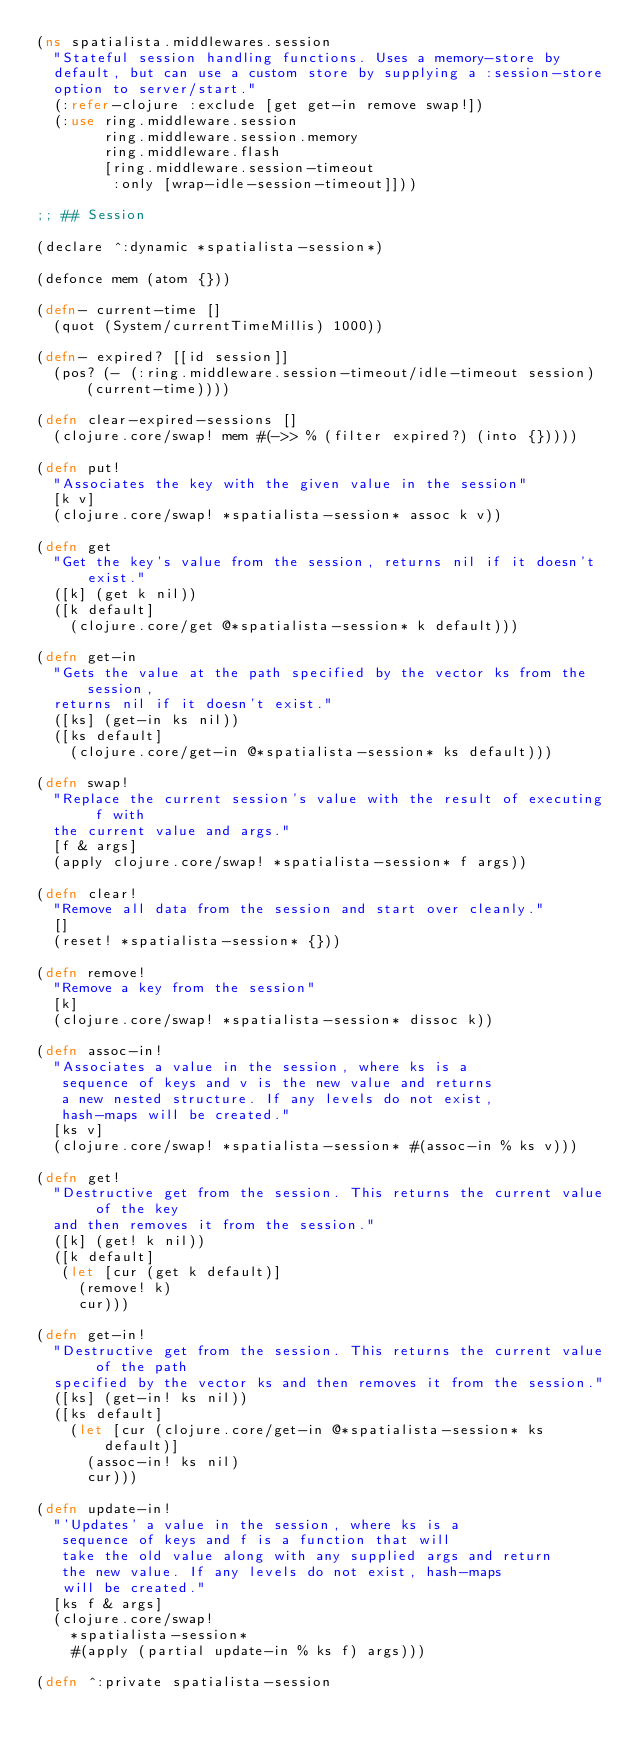<code> <loc_0><loc_0><loc_500><loc_500><_Clojure_>(ns spatialista.middlewares.session
  "Stateful session handling functions. Uses a memory-store by
  default, but can use a custom store by supplying a :session-store
  option to server/start."
  (:refer-clojure :exclude [get get-in remove swap!])
  (:use ring.middleware.session
        ring.middleware.session.memory
        ring.middleware.flash
        [ring.middleware.session-timeout
         :only [wrap-idle-session-timeout]]))

;; ## Session

(declare ^:dynamic *spatialista-session*)

(defonce mem (atom {}))

(defn- current-time []
  (quot (System/currentTimeMillis) 1000))

(defn- expired? [[id session]]
  (pos? (- (:ring.middleware.session-timeout/idle-timeout session) (current-time))))

(defn clear-expired-sessions []
  (clojure.core/swap! mem #(->> % (filter expired?) (into {}))))

(defn put!
  "Associates the key with the given value in the session"
  [k v]
  (clojure.core/swap! *spatialista-session* assoc k v))

(defn get
  "Get the key's value from the session, returns nil if it doesn't exist."
  ([k] (get k nil))
  ([k default]
    (clojure.core/get @*spatialista-session* k default)))

(defn get-in
  "Gets the value at the path specified by the vector ks from the session,
  returns nil if it doesn't exist."
  ([ks] (get-in ks nil))
  ([ks default]
    (clojure.core/get-in @*spatialista-session* ks default)))

(defn swap!
  "Replace the current session's value with the result of executing f with
  the current value and args."
  [f & args]
  (apply clojure.core/swap! *spatialista-session* f args))

(defn clear!
  "Remove all data from the session and start over cleanly."
  []
  (reset! *spatialista-session* {}))

(defn remove!
  "Remove a key from the session"
  [k]
  (clojure.core/swap! *spatialista-session* dissoc k))

(defn assoc-in!
  "Associates a value in the session, where ks is a
   sequence of keys and v is the new value and returns
   a new nested structure. If any levels do not exist,
   hash-maps will be created."
  [ks v]
  (clojure.core/swap! *spatialista-session* #(assoc-in % ks v)))

(defn get!
  "Destructive get from the session. This returns the current value of the key
  and then removes it from the session."
  ([k] (get! k nil))
  ([k default]
   (let [cur (get k default)]
     (remove! k)
     cur)))

(defn get-in!
  "Destructive get from the session. This returns the current value of the path
  specified by the vector ks and then removes it from the session."
  ([ks] (get-in! ks nil))
  ([ks default]
    (let [cur (clojure.core/get-in @*spatialista-session* ks default)]
      (assoc-in! ks nil)
      cur)))

(defn update-in!
  "'Updates' a value in the session, where ks is a
   sequence of keys and f is a function that will
   take the old value along with any supplied args and return
   the new value. If any levels do not exist, hash-maps
   will be created."
  [ks f & args]
  (clojure.core/swap!
    *spatialista-session*
    #(apply (partial update-in % ks f) args)))

(defn ^:private spatialista-session</code> 